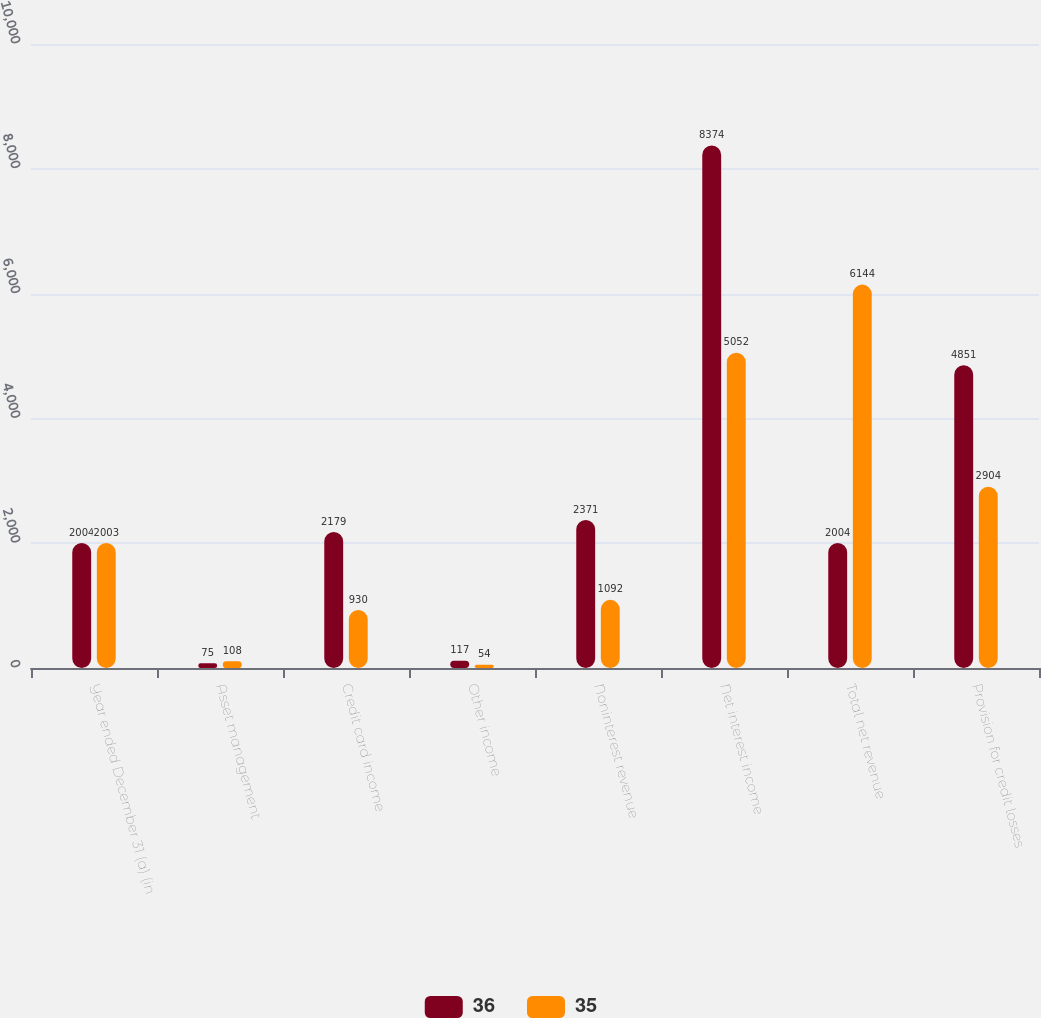Convert chart. <chart><loc_0><loc_0><loc_500><loc_500><stacked_bar_chart><ecel><fcel>Year ended December 31 (a) (in<fcel>Asset management<fcel>Credit card income<fcel>Other income<fcel>Noninterest revenue<fcel>Net interest income<fcel>Total net revenue<fcel>Provision for credit losses<nl><fcel>36<fcel>2004<fcel>75<fcel>2179<fcel>117<fcel>2371<fcel>8374<fcel>2004<fcel>4851<nl><fcel>35<fcel>2003<fcel>108<fcel>930<fcel>54<fcel>1092<fcel>5052<fcel>6144<fcel>2904<nl></chart> 